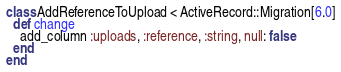<code> <loc_0><loc_0><loc_500><loc_500><_Ruby_>class AddReferenceToUpload < ActiveRecord::Migration[6.0]
  def change
    add_column :uploads, :reference, :string, null: false
  end
end
</code> 